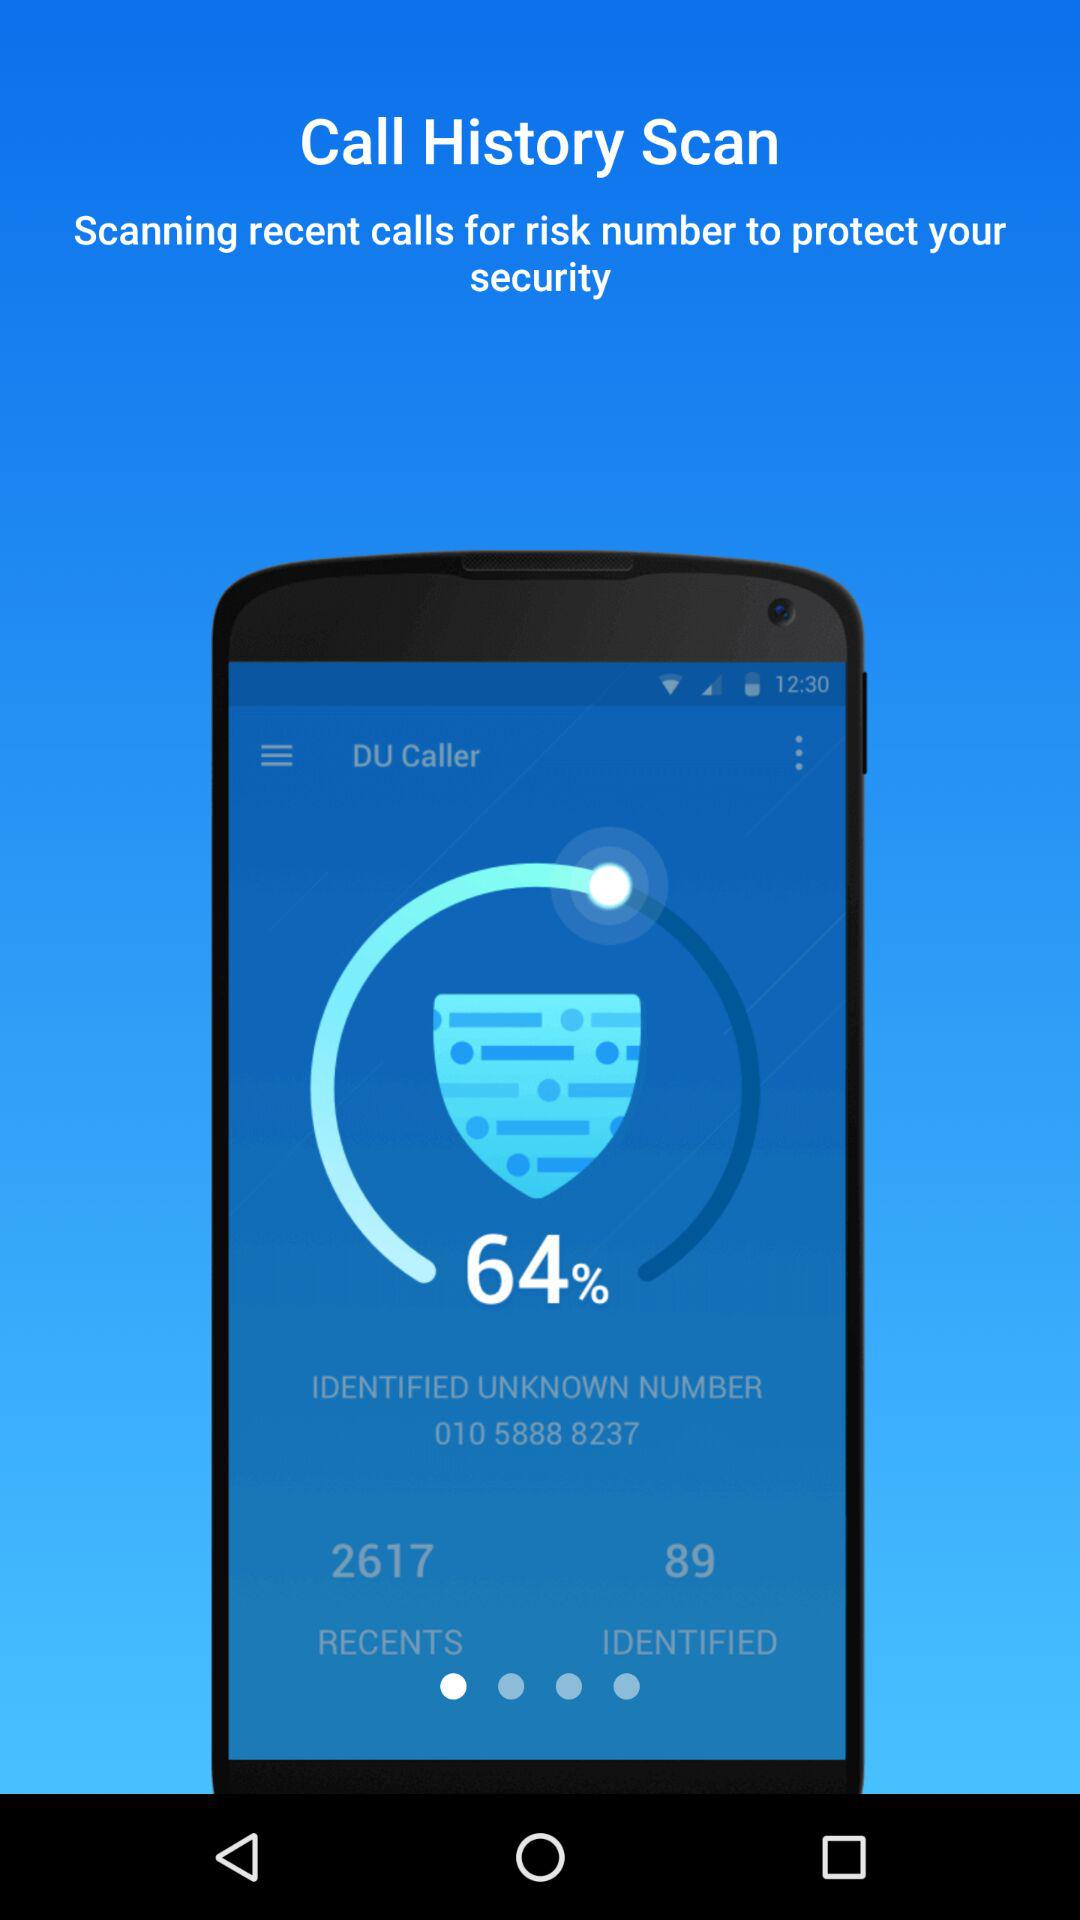What percentage of calls are identified?
Answer the question using a single word or phrase. 64% 